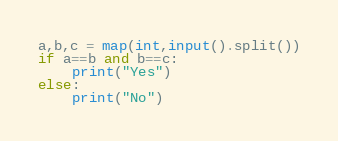<code> <loc_0><loc_0><loc_500><loc_500><_Python_>a,b,c = map(int,input().split())
if a==b and b==c:
    print("Yes")
else:
    print("No")</code> 